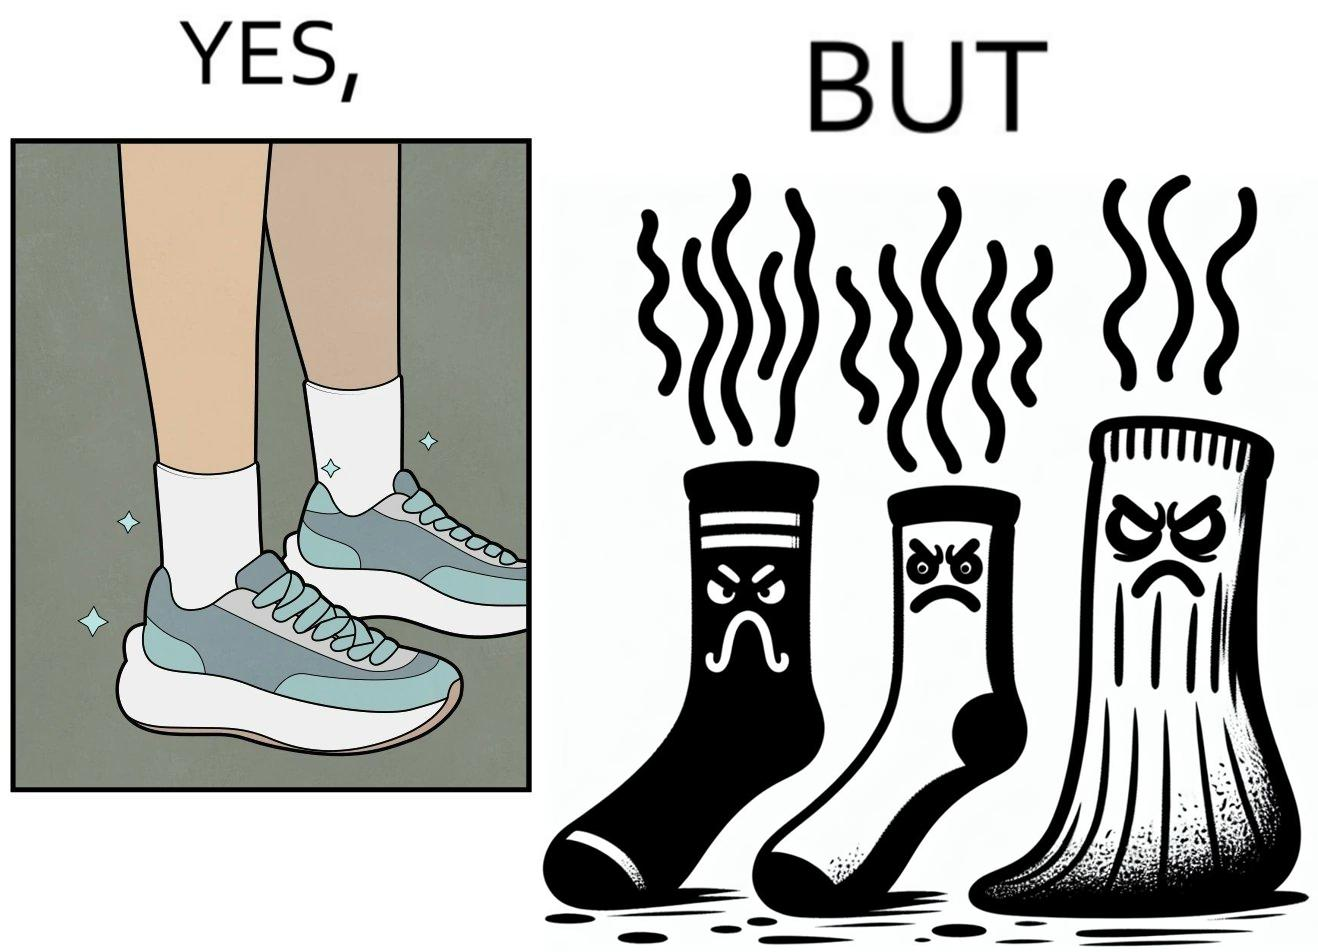What do you see in each half of this image? In the left part of the image: The image is showing neat and clean shoes. In the right part of the image: The image is showing dirty shocks. 